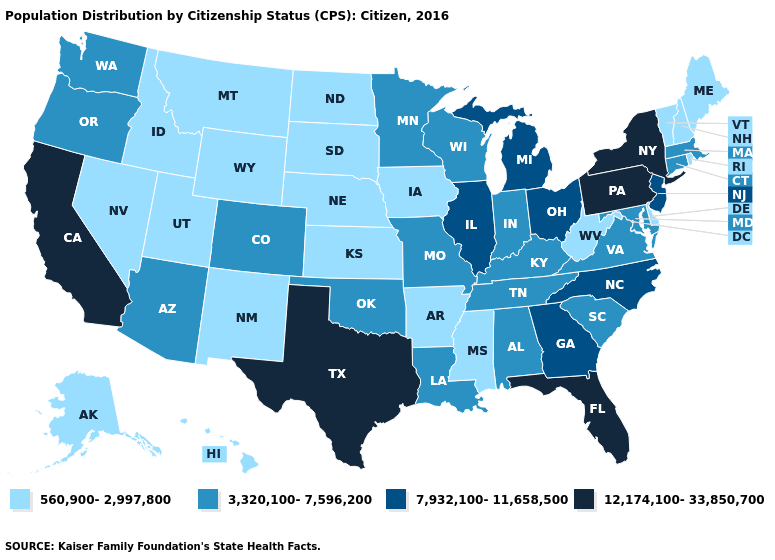Name the states that have a value in the range 3,320,100-7,596,200?
Keep it brief. Alabama, Arizona, Colorado, Connecticut, Indiana, Kentucky, Louisiana, Maryland, Massachusetts, Minnesota, Missouri, Oklahoma, Oregon, South Carolina, Tennessee, Virginia, Washington, Wisconsin. What is the lowest value in the Northeast?
Give a very brief answer. 560,900-2,997,800. Does the map have missing data?
Answer briefly. No. What is the value of Mississippi?
Answer briefly. 560,900-2,997,800. Does Illinois have the same value as New Hampshire?
Write a very short answer. No. What is the value of Minnesota?
Write a very short answer. 3,320,100-7,596,200. Name the states that have a value in the range 7,932,100-11,658,500?
Write a very short answer. Georgia, Illinois, Michigan, New Jersey, North Carolina, Ohio. Which states have the lowest value in the South?
Give a very brief answer. Arkansas, Delaware, Mississippi, West Virginia. What is the value of Connecticut?
Short answer required. 3,320,100-7,596,200. What is the highest value in states that border Louisiana?
Be succinct. 12,174,100-33,850,700. What is the value of Wyoming?
Keep it brief. 560,900-2,997,800. What is the value of Missouri?
Give a very brief answer. 3,320,100-7,596,200. Name the states that have a value in the range 3,320,100-7,596,200?
Keep it brief. Alabama, Arizona, Colorado, Connecticut, Indiana, Kentucky, Louisiana, Maryland, Massachusetts, Minnesota, Missouri, Oklahoma, Oregon, South Carolina, Tennessee, Virginia, Washington, Wisconsin. Name the states that have a value in the range 3,320,100-7,596,200?
Write a very short answer. Alabama, Arizona, Colorado, Connecticut, Indiana, Kentucky, Louisiana, Maryland, Massachusetts, Minnesota, Missouri, Oklahoma, Oregon, South Carolina, Tennessee, Virginia, Washington, Wisconsin. 